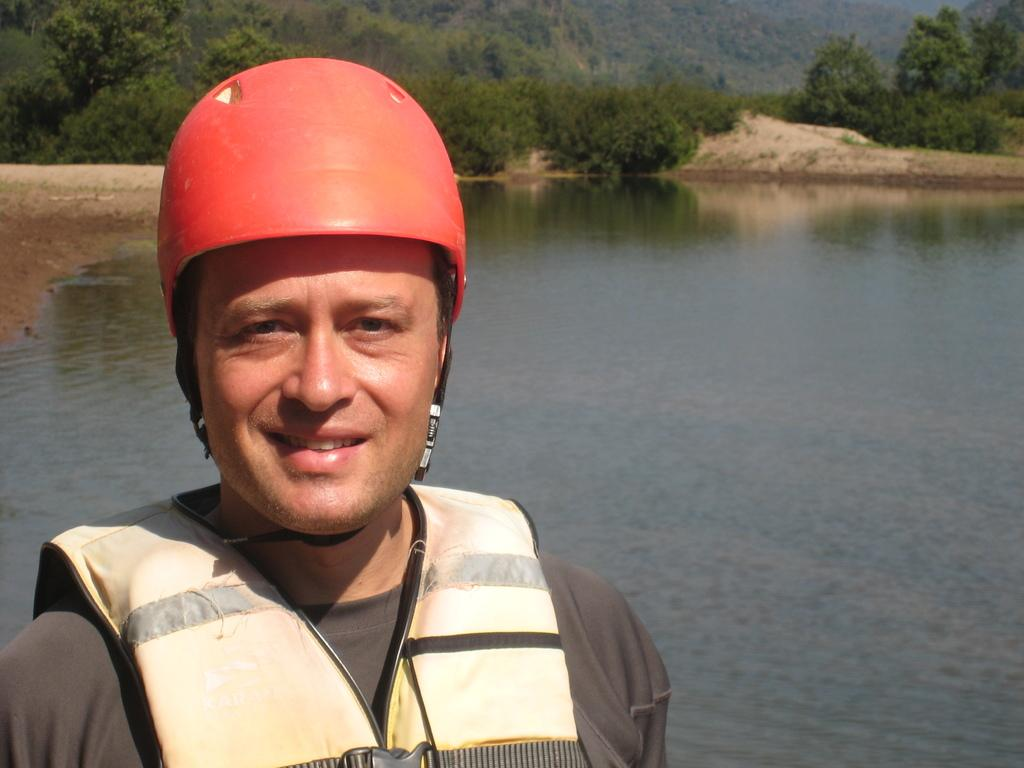Who is present in the image? There is a man in the image. What is the man wearing on his head? The man is wearing a red helmet. What protective gear is the man wearing? The man is wearing a life jacket. What can be seen in the background of the image? There is water visible in the background of the image, with trees behind the water and sand behind the water and trees. What type of milk is the man drinking in the image? There is no milk present in the image; the man is wearing a red helmet and a life jacket, and there is water visible in the background. 